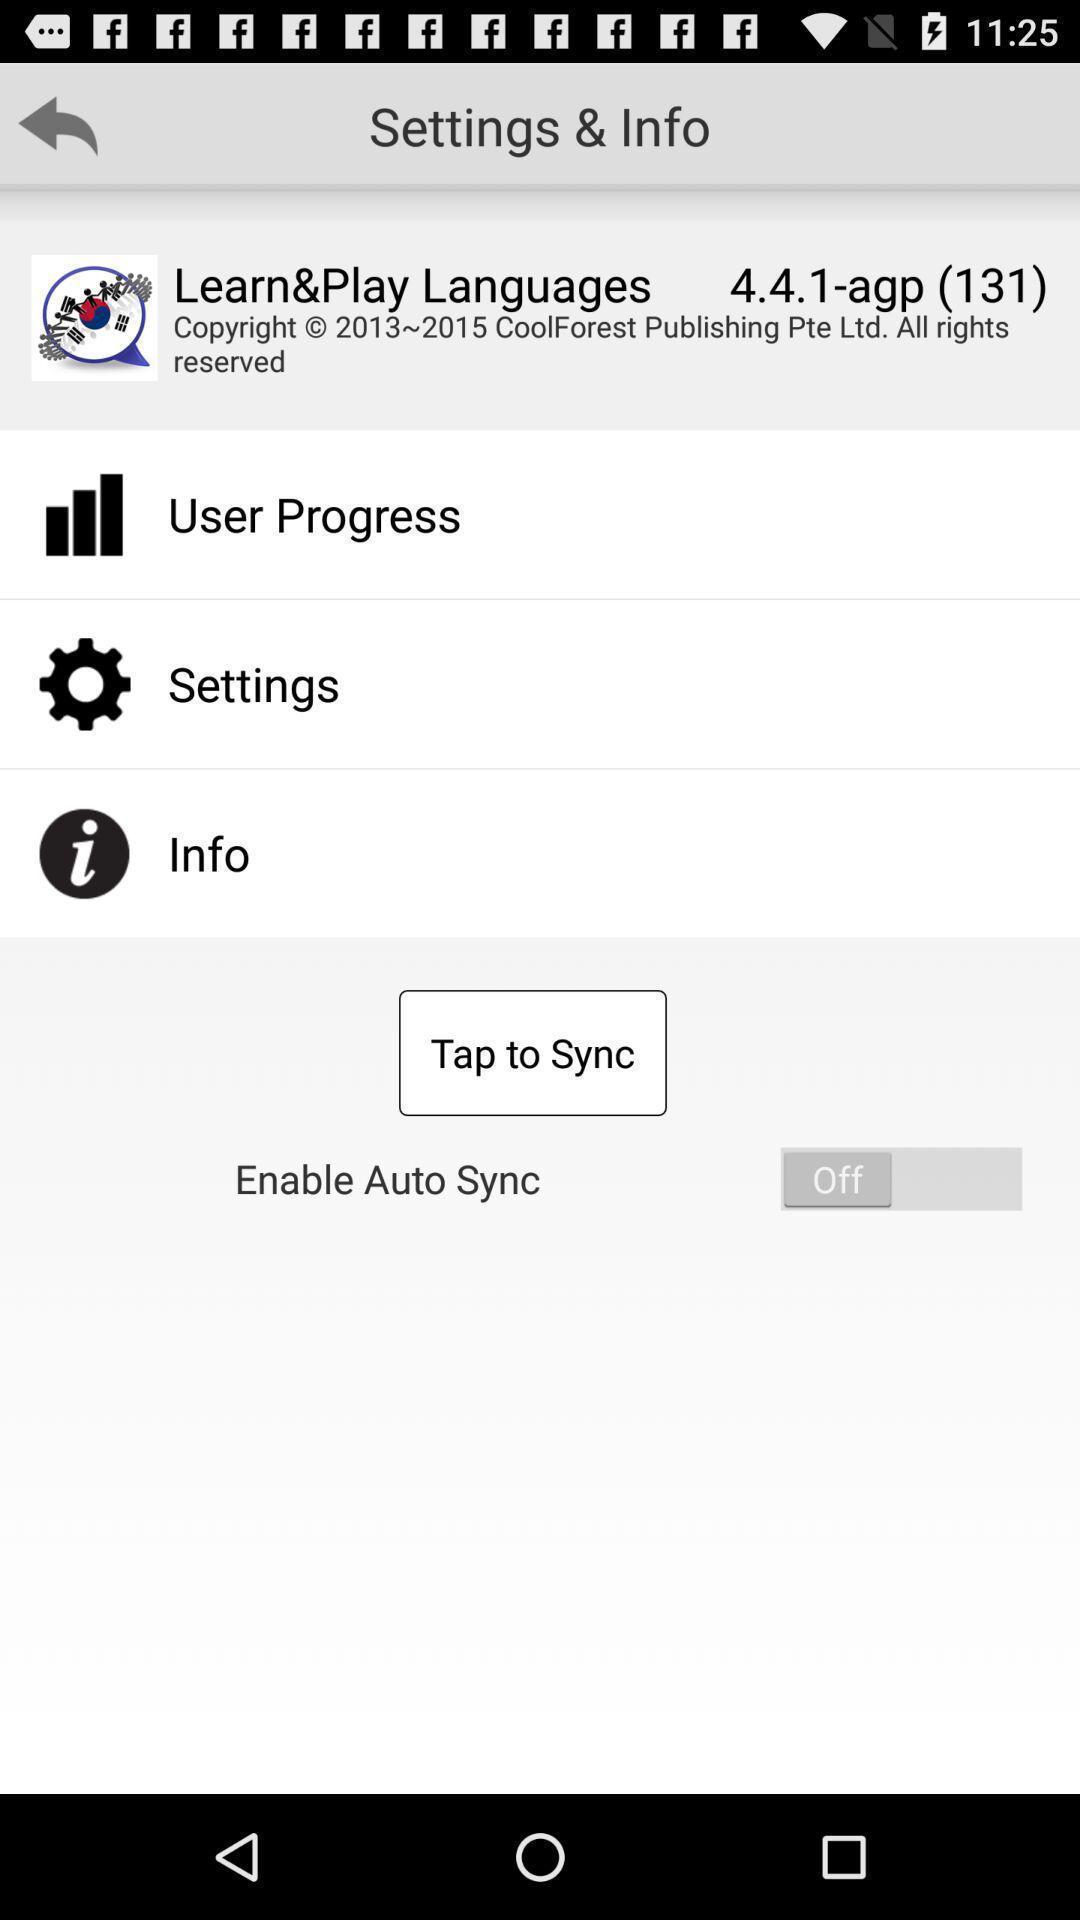What is the overall content of this screenshot? Settings of a language learning app are displaying. 